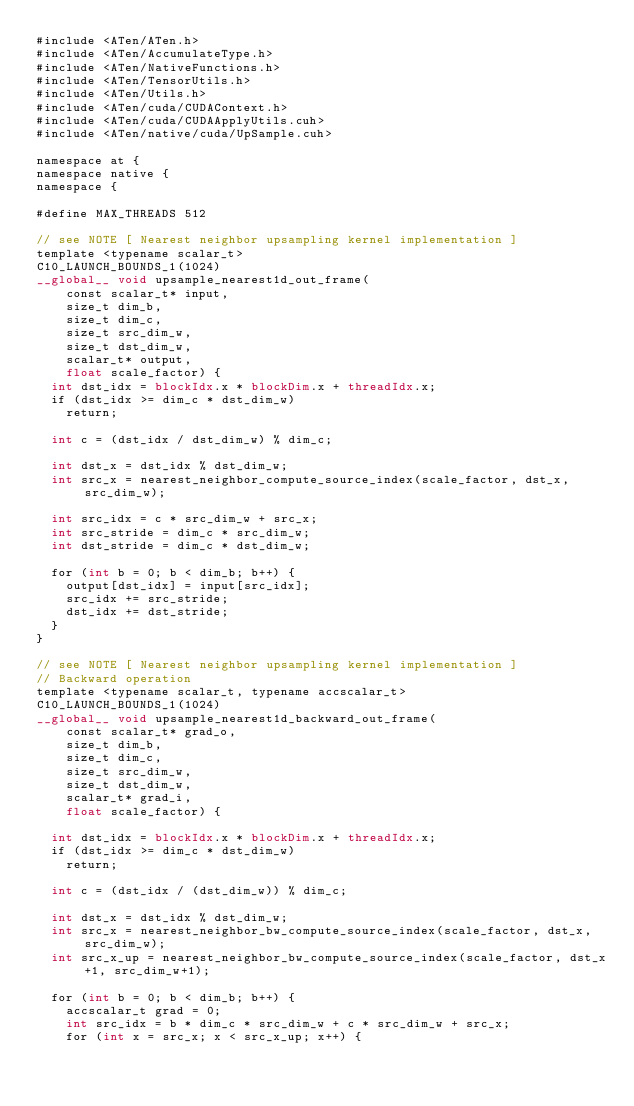<code> <loc_0><loc_0><loc_500><loc_500><_Cuda_>#include <ATen/ATen.h>
#include <ATen/AccumulateType.h>
#include <ATen/NativeFunctions.h>
#include <ATen/TensorUtils.h>
#include <ATen/Utils.h>
#include <ATen/cuda/CUDAContext.h>
#include <ATen/cuda/CUDAApplyUtils.cuh>
#include <ATen/native/cuda/UpSample.cuh>

namespace at {
namespace native {
namespace {

#define MAX_THREADS 512

// see NOTE [ Nearest neighbor upsampling kernel implementation ]
template <typename scalar_t>
C10_LAUNCH_BOUNDS_1(1024)
__global__ void upsample_nearest1d_out_frame(
    const scalar_t* input,
    size_t dim_b,
    size_t dim_c,
    size_t src_dim_w,
    size_t dst_dim_w,
    scalar_t* output,
    float scale_factor) {
  int dst_idx = blockIdx.x * blockDim.x + threadIdx.x;
  if (dst_idx >= dim_c * dst_dim_w)
    return;

  int c = (dst_idx / dst_dim_w) % dim_c;

  int dst_x = dst_idx % dst_dim_w;
  int src_x = nearest_neighbor_compute_source_index(scale_factor, dst_x, src_dim_w);

  int src_idx = c * src_dim_w + src_x;
  int src_stride = dim_c * src_dim_w;
  int dst_stride = dim_c * dst_dim_w;

  for (int b = 0; b < dim_b; b++) {
    output[dst_idx] = input[src_idx];
    src_idx += src_stride;
    dst_idx += dst_stride;
  }
}

// see NOTE [ Nearest neighbor upsampling kernel implementation ]
// Backward operation
template <typename scalar_t, typename accscalar_t>
C10_LAUNCH_BOUNDS_1(1024)
__global__ void upsample_nearest1d_backward_out_frame(
    const scalar_t* grad_o,
    size_t dim_b,
    size_t dim_c,
    size_t src_dim_w,
    size_t dst_dim_w,
    scalar_t* grad_i,
    float scale_factor) {

  int dst_idx = blockIdx.x * blockDim.x + threadIdx.x;
  if (dst_idx >= dim_c * dst_dim_w)
    return;

  int c = (dst_idx / (dst_dim_w)) % dim_c;

  int dst_x = dst_idx % dst_dim_w;
  int src_x = nearest_neighbor_bw_compute_source_index(scale_factor, dst_x, src_dim_w);
  int src_x_up = nearest_neighbor_bw_compute_source_index(scale_factor, dst_x+1, src_dim_w+1);

  for (int b = 0; b < dim_b; b++) {
    accscalar_t grad = 0;
    int src_idx = b * dim_c * src_dim_w + c * src_dim_w + src_x;
    for (int x = src_x; x < src_x_up; x++) {</code> 